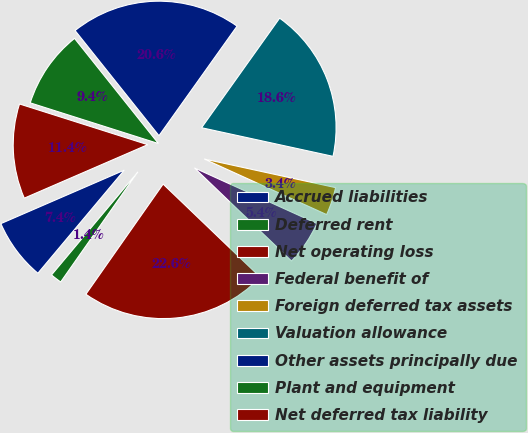<chart> <loc_0><loc_0><loc_500><loc_500><pie_chart><fcel>Accrued liabilities<fcel>Deferred rent<fcel>Net operating loss<fcel>Federal benefit of<fcel>Foreign deferred tax assets<fcel>Valuation allowance<fcel>Other assets principally due<fcel>Plant and equipment<fcel>Net deferred tax liability<nl><fcel>7.39%<fcel>1.37%<fcel>22.57%<fcel>5.38%<fcel>3.37%<fcel>18.56%<fcel>20.57%<fcel>9.39%<fcel>11.4%<nl></chart> 